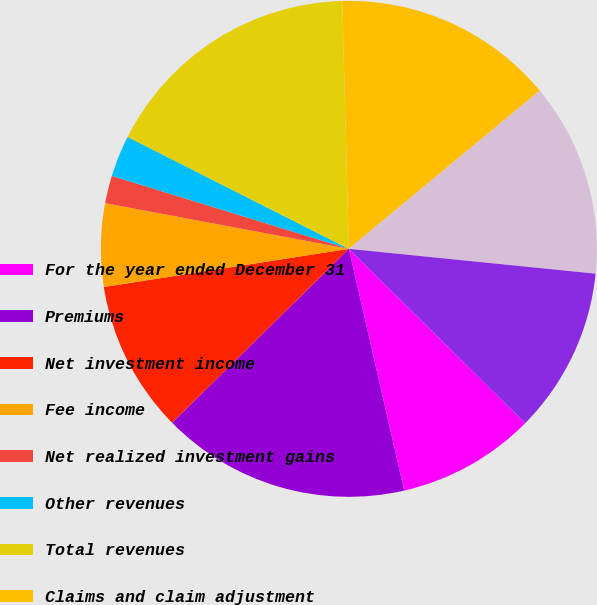<chart> <loc_0><loc_0><loc_500><loc_500><pie_chart><fcel>For the year ended December 31<fcel>Premiums<fcel>Net investment income<fcel>Fee income<fcel>Net realized investment gains<fcel>Other revenues<fcel>Total revenues<fcel>Claims and claim adjustment<fcel>Amortization of deferred<fcel>General and administrative<nl><fcel>9.01%<fcel>16.21%<fcel>9.91%<fcel>5.41%<fcel>1.8%<fcel>2.7%<fcel>17.12%<fcel>14.41%<fcel>12.61%<fcel>10.81%<nl></chart> 